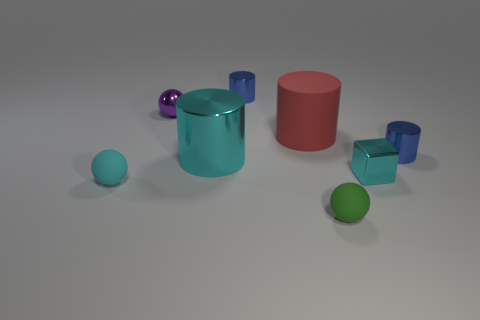Subtract 1 cylinders. How many cylinders are left? 3 Subtract all green cylinders. Subtract all cyan cubes. How many cylinders are left? 4 Add 1 purple spheres. How many objects exist? 9 Subtract all spheres. How many objects are left? 5 Subtract 0 red cubes. How many objects are left? 8 Subtract all big metal cylinders. Subtract all red things. How many objects are left? 6 Add 7 tiny blocks. How many tiny blocks are left? 8 Add 4 cylinders. How many cylinders exist? 8 